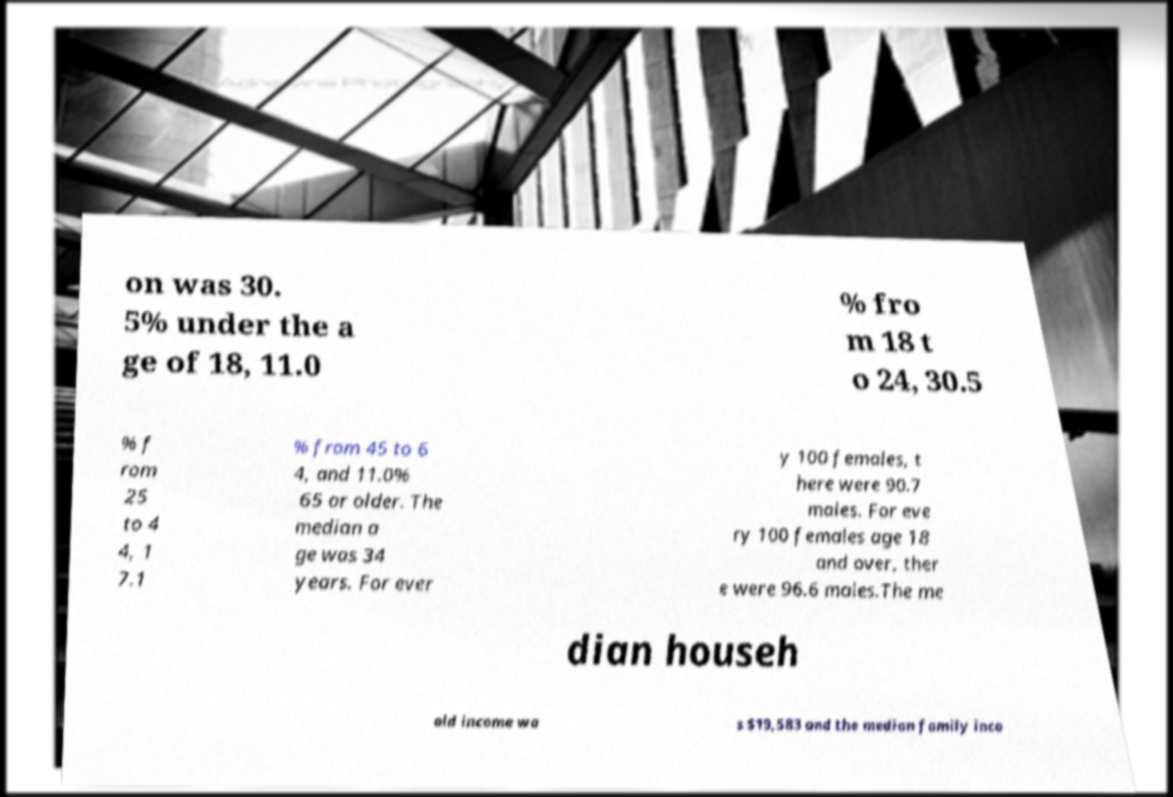What messages or text are displayed in this image? I need them in a readable, typed format. on was 30. 5% under the a ge of 18, 11.0 % fro m 18 t o 24, 30.5 % f rom 25 to 4 4, 1 7.1 % from 45 to 6 4, and 11.0% 65 or older. The median a ge was 34 years. For ever y 100 females, t here were 90.7 males. For eve ry 100 females age 18 and over, ther e were 96.6 males.The me dian househ old income wa s $19,583 and the median family inco 